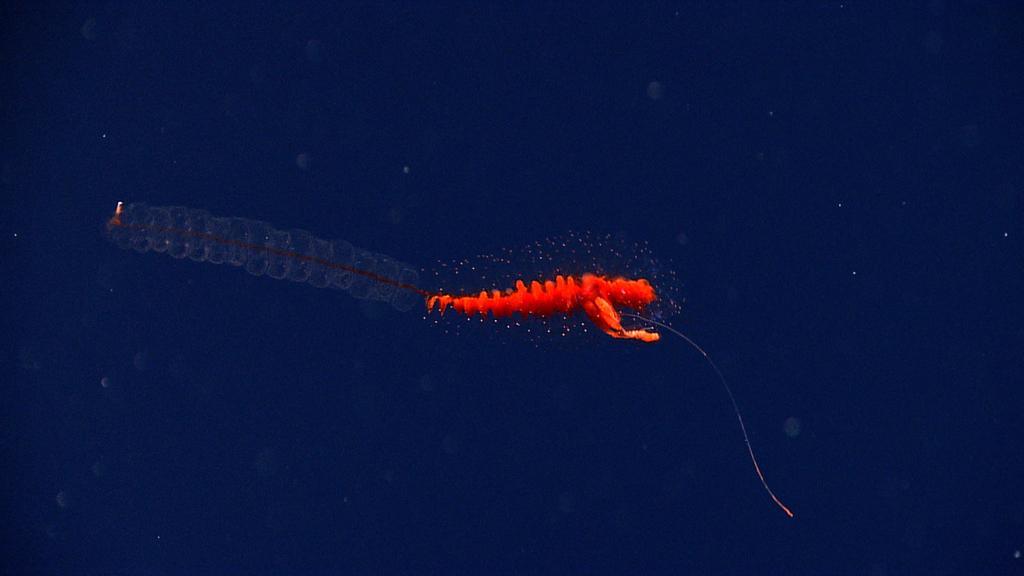Can you describe this image briefly? In this image we can see a red colored invertebrate which looks like a aquatic animal. 